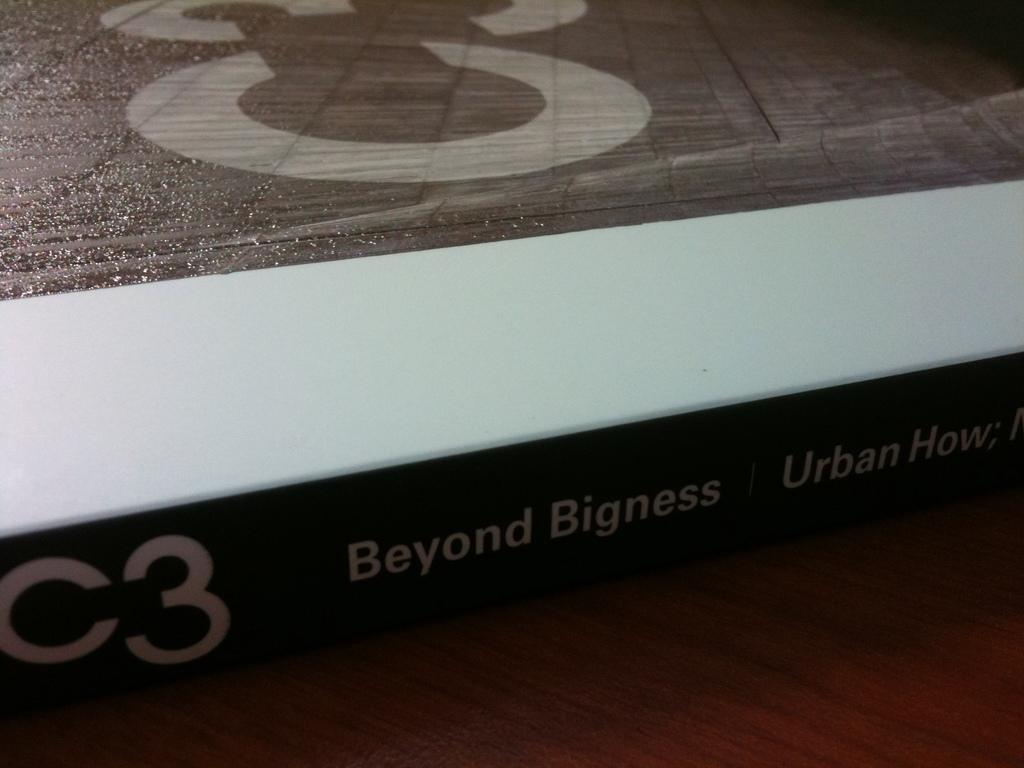<image>
Give a short and clear explanation of the subsequent image. A book that says C3 Beyond bigness on it. 